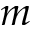<formula> <loc_0><loc_0><loc_500><loc_500>m</formula> 